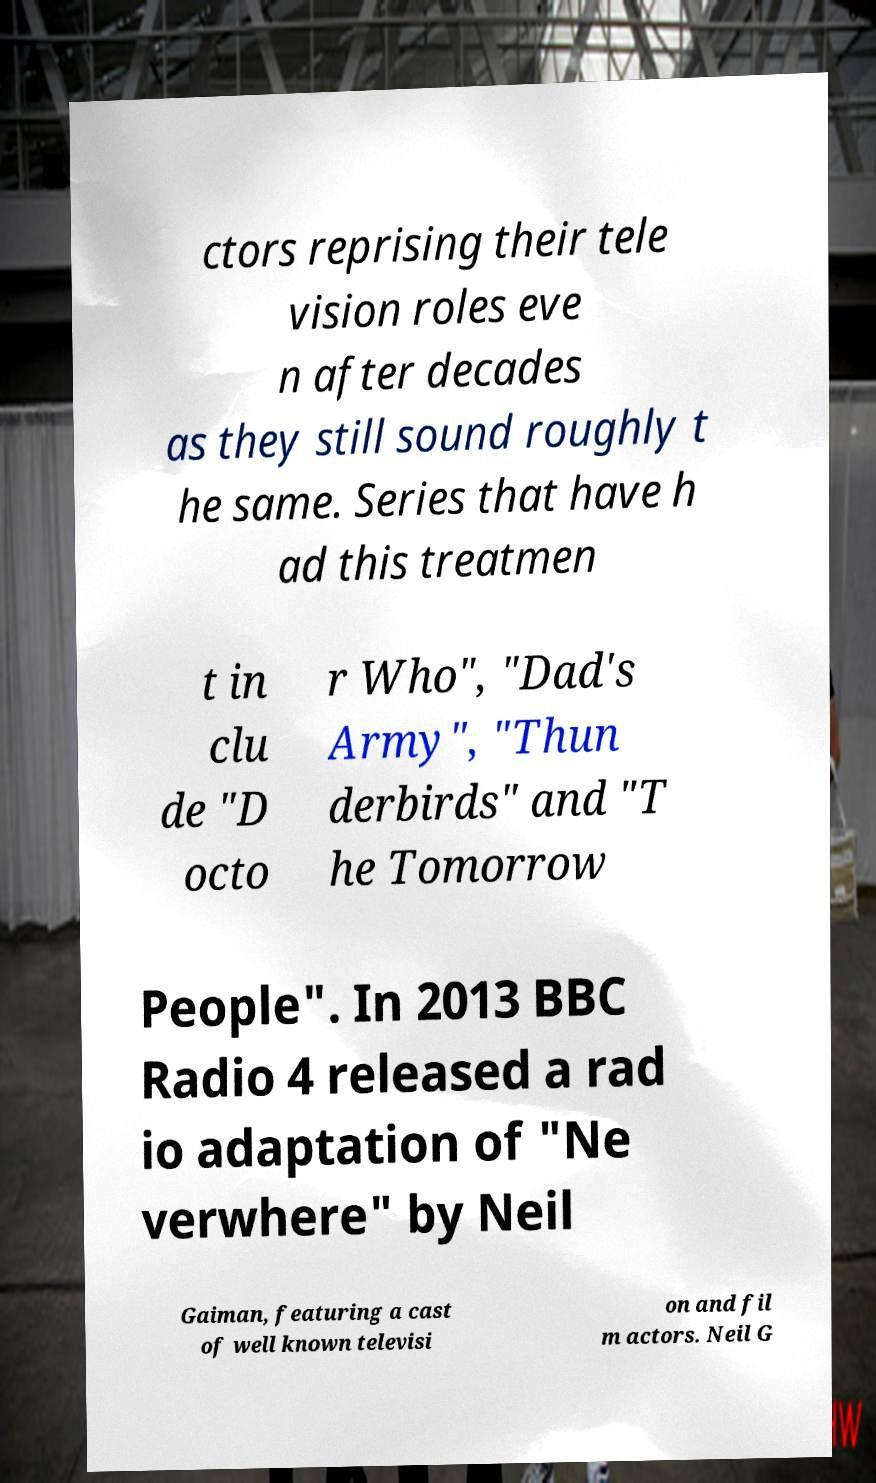Please identify and transcribe the text found in this image. ctors reprising their tele vision roles eve n after decades as they still sound roughly t he same. Series that have h ad this treatmen t in clu de "D octo r Who", "Dad's Army", "Thun derbirds" and "T he Tomorrow People". In 2013 BBC Radio 4 released a rad io adaptation of "Ne verwhere" by Neil Gaiman, featuring a cast of well known televisi on and fil m actors. Neil G 